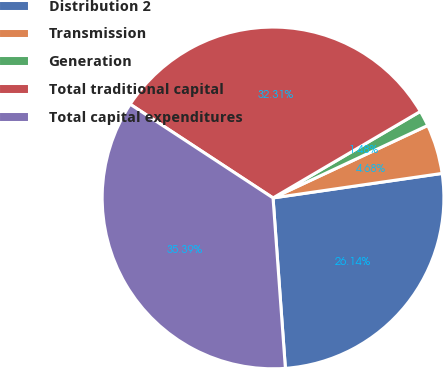Convert chart to OTSL. <chart><loc_0><loc_0><loc_500><loc_500><pie_chart><fcel>Distribution 2<fcel>Transmission<fcel>Generation<fcel>Total traditional capital<fcel>Total capital expenditures<nl><fcel>26.14%<fcel>4.68%<fcel>1.48%<fcel>32.31%<fcel>35.39%<nl></chart> 